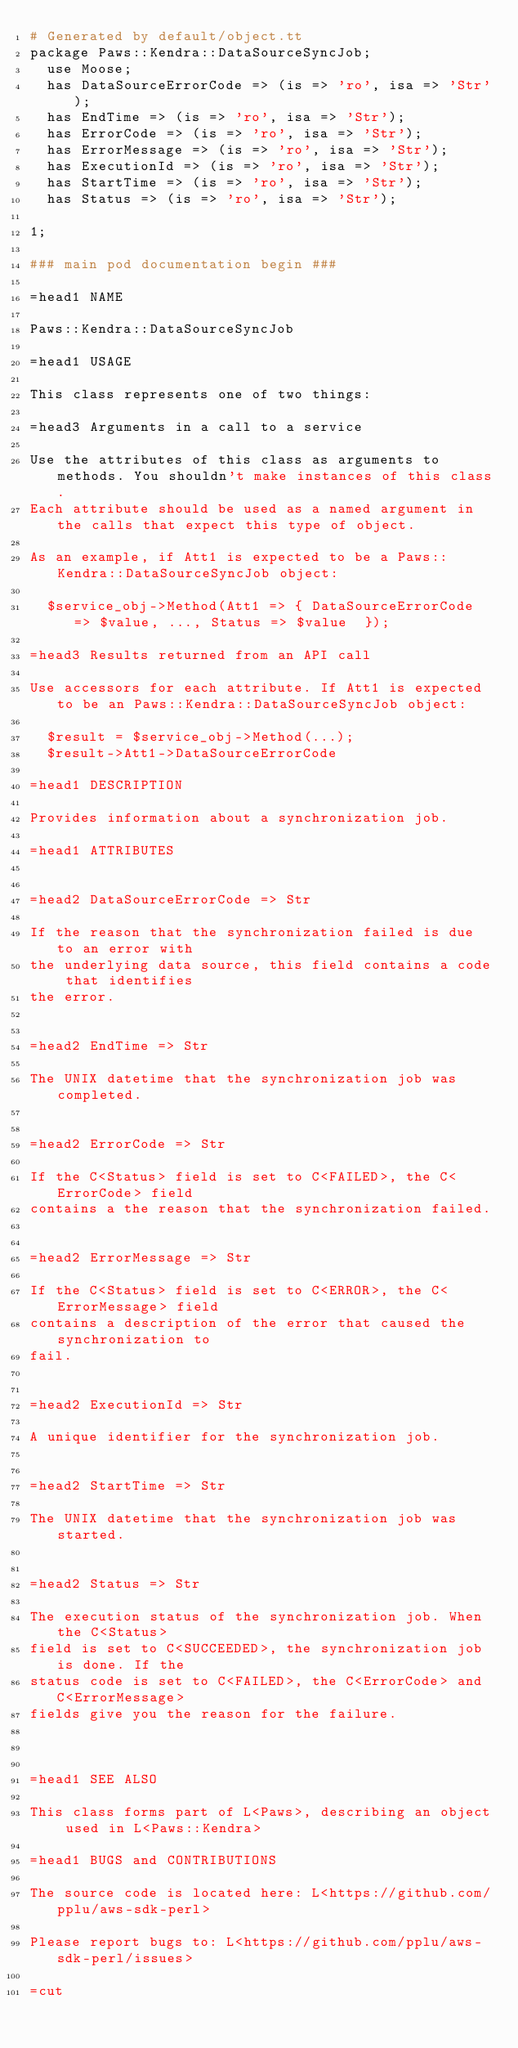Convert code to text. <code><loc_0><loc_0><loc_500><loc_500><_Perl_># Generated by default/object.tt
package Paws::Kendra::DataSourceSyncJob;
  use Moose;
  has DataSourceErrorCode => (is => 'ro', isa => 'Str');
  has EndTime => (is => 'ro', isa => 'Str');
  has ErrorCode => (is => 'ro', isa => 'Str');
  has ErrorMessage => (is => 'ro', isa => 'Str');
  has ExecutionId => (is => 'ro', isa => 'Str');
  has StartTime => (is => 'ro', isa => 'Str');
  has Status => (is => 'ro', isa => 'Str');

1;

### main pod documentation begin ###

=head1 NAME

Paws::Kendra::DataSourceSyncJob

=head1 USAGE

This class represents one of two things:

=head3 Arguments in a call to a service

Use the attributes of this class as arguments to methods. You shouldn't make instances of this class. 
Each attribute should be used as a named argument in the calls that expect this type of object.

As an example, if Att1 is expected to be a Paws::Kendra::DataSourceSyncJob object:

  $service_obj->Method(Att1 => { DataSourceErrorCode => $value, ..., Status => $value  });

=head3 Results returned from an API call

Use accessors for each attribute. If Att1 is expected to be an Paws::Kendra::DataSourceSyncJob object:

  $result = $service_obj->Method(...);
  $result->Att1->DataSourceErrorCode

=head1 DESCRIPTION

Provides information about a synchronization job.

=head1 ATTRIBUTES


=head2 DataSourceErrorCode => Str

If the reason that the synchronization failed is due to an error with
the underlying data source, this field contains a code that identifies
the error.


=head2 EndTime => Str

The UNIX datetime that the synchronization job was completed.


=head2 ErrorCode => Str

If the C<Status> field is set to C<FAILED>, the C<ErrorCode> field
contains a the reason that the synchronization failed.


=head2 ErrorMessage => Str

If the C<Status> field is set to C<ERROR>, the C<ErrorMessage> field
contains a description of the error that caused the synchronization to
fail.


=head2 ExecutionId => Str

A unique identifier for the synchronization job.


=head2 StartTime => Str

The UNIX datetime that the synchronization job was started.


=head2 Status => Str

The execution status of the synchronization job. When the C<Status>
field is set to C<SUCCEEDED>, the synchronization job is done. If the
status code is set to C<FAILED>, the C<ErrorCode> and C<ErrorMessage>
fields give you the reason for the failure.



=head1 SEE ALSO

This class forms part of L<Paws>, describing an object used in L<Paws::Kendra>

=head1 BUGS and CONTRIBUTIONS

The source code is located here: L<https://github.com/pplu/aws-sdk-perl>

Please report bugs to: L<https://github.com/pplu/aws-sdk-perl/issues>

=cut

</code> 